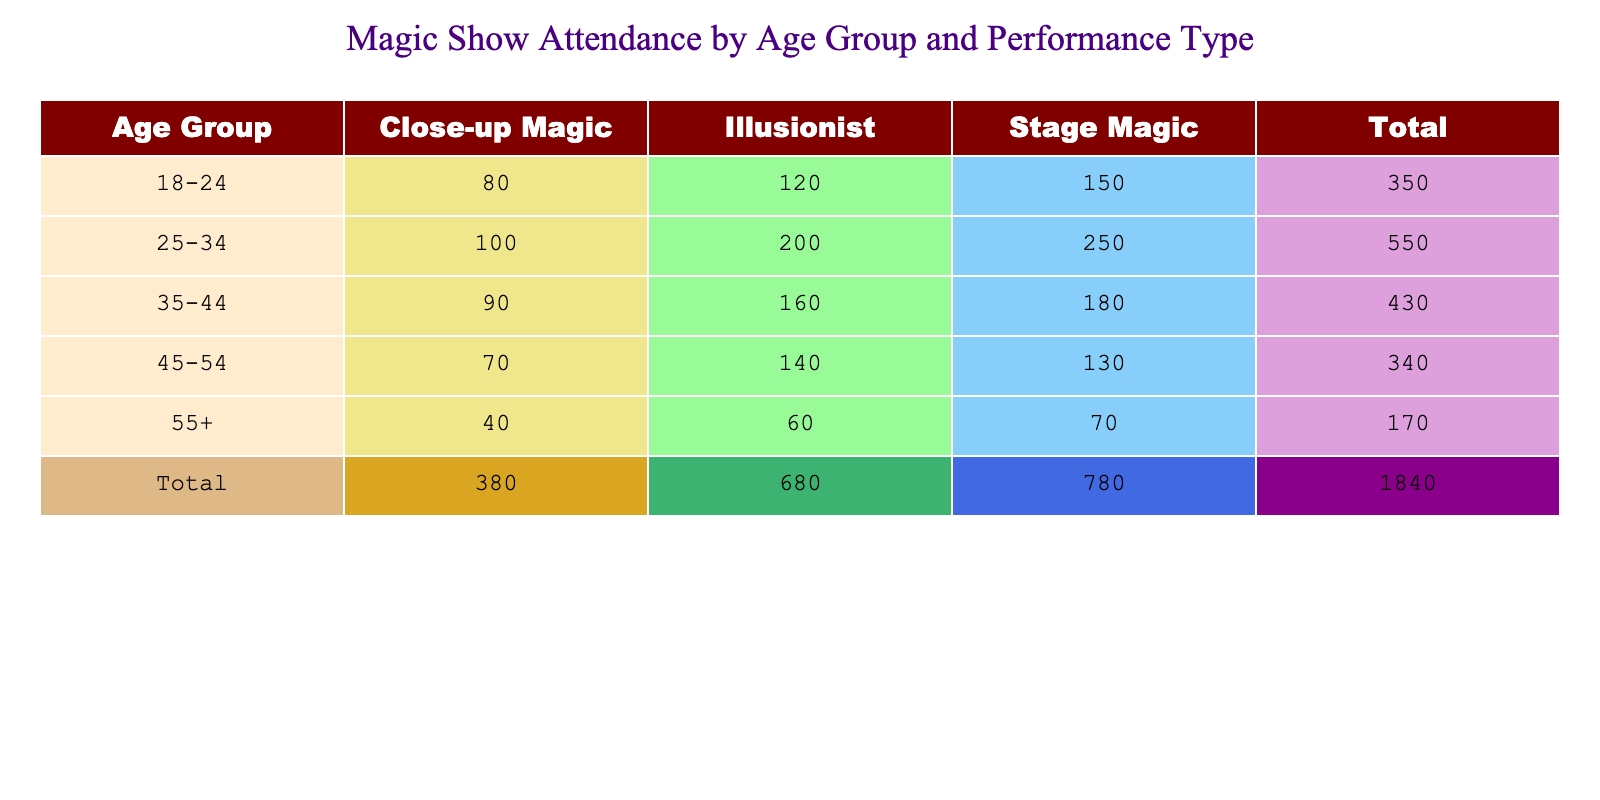What is the total attendance for the 25-34 age group across all performance types? To find the total attendance for the 25-34 age group, look at the attendance values under this age group: Illusionist (200), Close-up Magic (100), and Stage Magic (250). Summing these values: 200 + 100 + 250 = 550.
Answer: 550 How many attendees watched Close-up Magic performances in the 45-54 age group? The attendance for Close-up Magic in the 45-54 age group is directly listed in the table as 70.
Answer: 70 Which performance type had the highest attendance for the 18-24 age group? Checking the attendance values for the 18-24 age group: Illusionist (120), Close-up Magic (80), and Stage Magic (150). The highest value is 150 for Stage Magic.
Answer: Stage Magic Is the attendance for Illusionist performances higher in the 35-44 age group than in the 55+ group? The attendance for Illusionist in the 35-44 age group is 160 and in the 55+ group is 60. Since 160 is greater than 60, the statement is true.
Answer: Yes What is the average attendance for Stage Magic across all age groups? To find the average for Stage Magic, sum the attendances: 150 (18-24) + 250 (25-34) + 180 (35-44) + 130 (45-54) + 70 (55+) = 780. There are 5 age groups, so average attendance = 780 / 5 = 156.
Answer: 156 What is the difference in attendance between the 25-34 age group for Illusionist and the 45-54 age group for Close-up Magic? The 25-34 age group's attendance for Illusionist is 200 and the 45-54 age group's attendance for Close-up Magic is 70. The difference is 200 - 70 = 130.
Answer: 130 Does the total attendance for the 55+ age group exceed 200 across all performance types? The total attendance for 55+ is: Illusionist (60) + Close-up Magic (40) + Stage Magic (70) = 170. Since 170 is less than 200, the statement is false.
Answer: No Which age group had the highest overall attendance? Calculate the total attendance for each age group: 18-24 (120 + 80 + 150 = 350), 25-34 (200 + 100 + 250 = 550), 35-44 (160 + 90 + 180 = 430), 45-54 (140 + 70 + 130 = 340), 55+ (60 + 40 + 70 = 170). The highest is 550 for the 25-34 age group.
Answer: 25-34 age group 